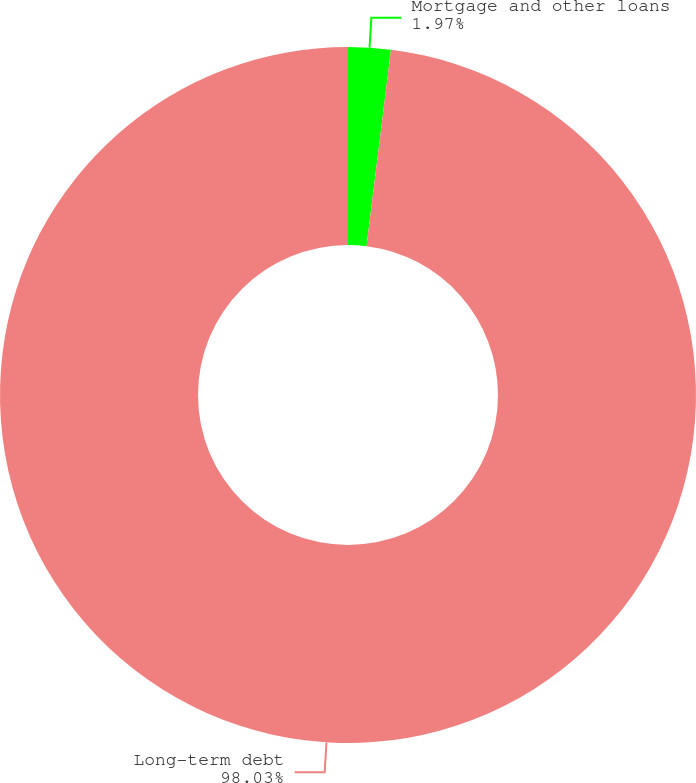Convert chart. <chart><loc_0><loc_0><loc_500><loc_500><pie_chart><fcel>Mortgage and other loans<fcel>Long-term debt<nl><fcel>1.97%<fcel>98.03%<nl></chart> 